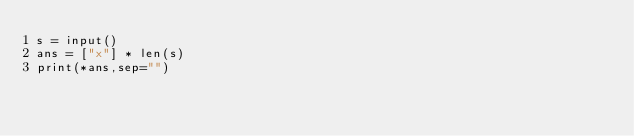<code> <loc_0><loc_0><loc_500><loc_500><_Python_>s = input()
ans = ["x"] * len(s)
print(*ans,sep="")</code> 